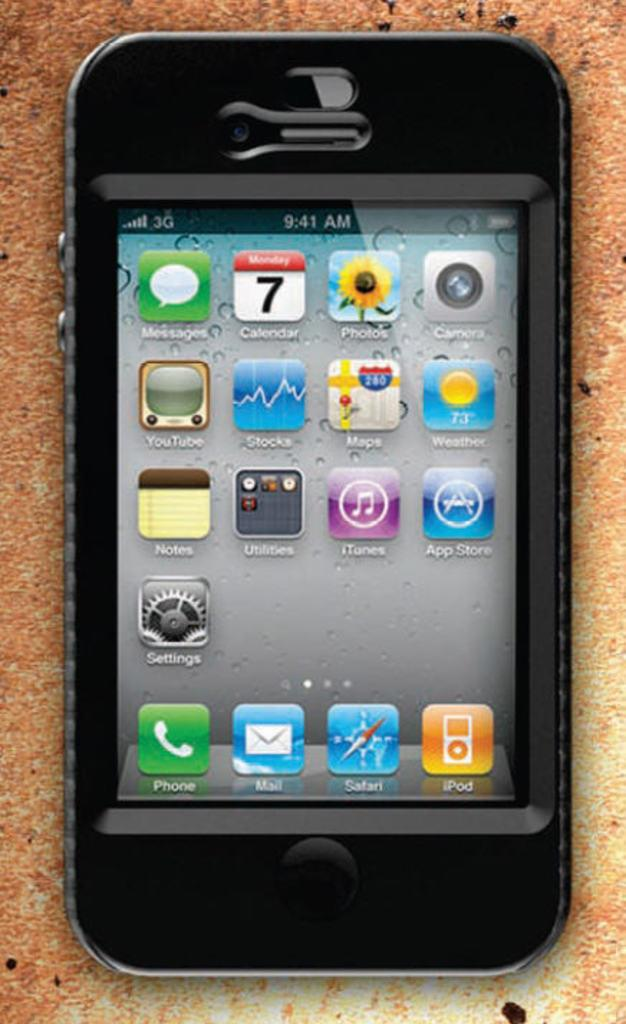<image>
Relay a brief, clear account of the picture shown. A smart phone that shows it being 9:41 am. 